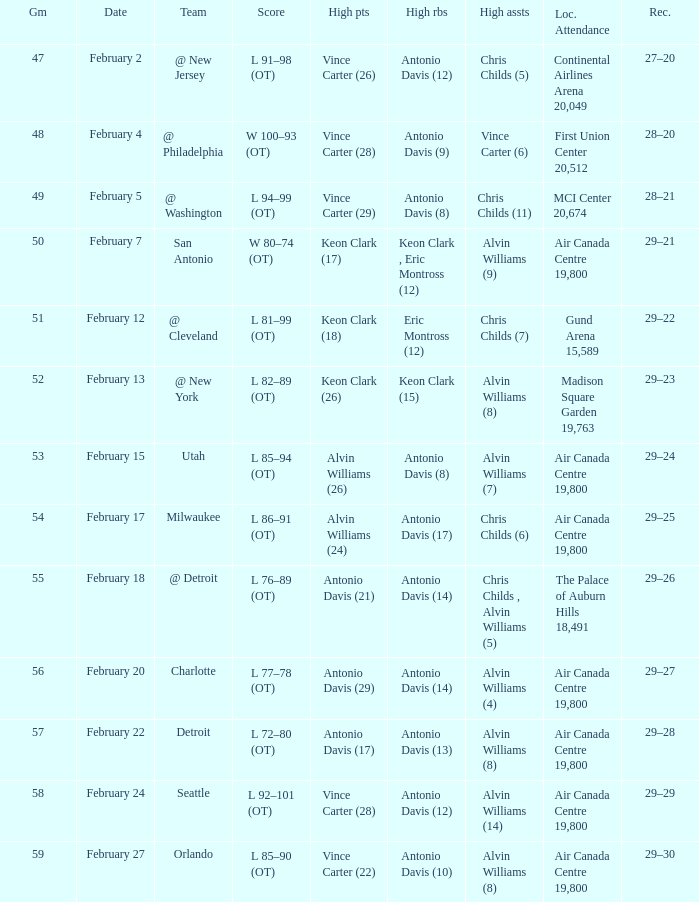What is the Record when the high rebounds was Antonio Davis (9)? 28–20. 